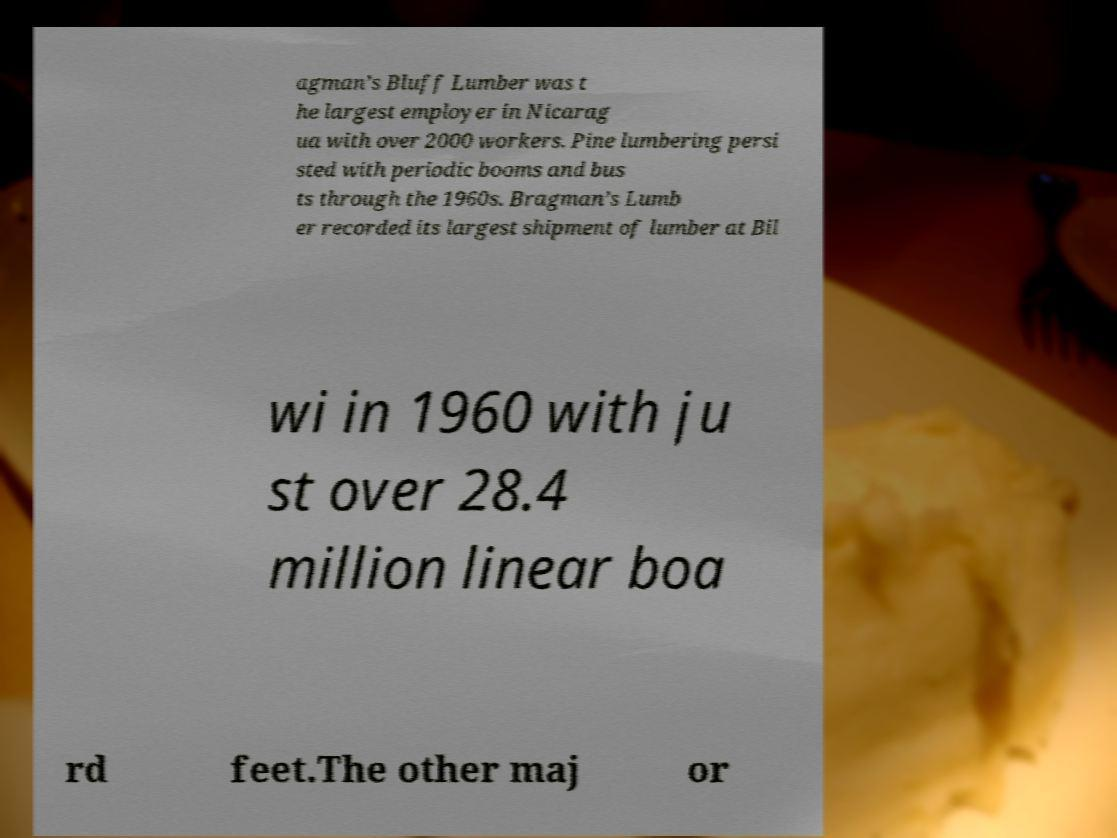There's text embedded in this image that I need extracted. Can you transcribe it verbatim? agman’s Bluff Lumber was t he largest employer in Nicarag ua with over 2000 workers. Pine lumbering persi sted with periodic booms and bus ts through the 1960s. Bragman’s Lumb er recorded its largest shipment of lumber at Bil wi in 1960 with ju st over 28.4 million linear boa rd feet.The other maj or 